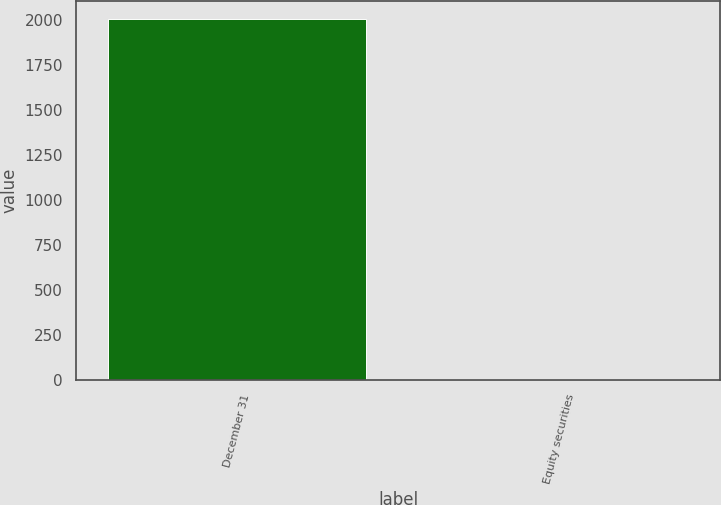Convert chart. <chart><loc_0><loc_0><loc_500><loc_500><bar_chart><fcel>December 31<fcel>Equity securities<nl><fcel>2007<fcel>6<nl></chart> 